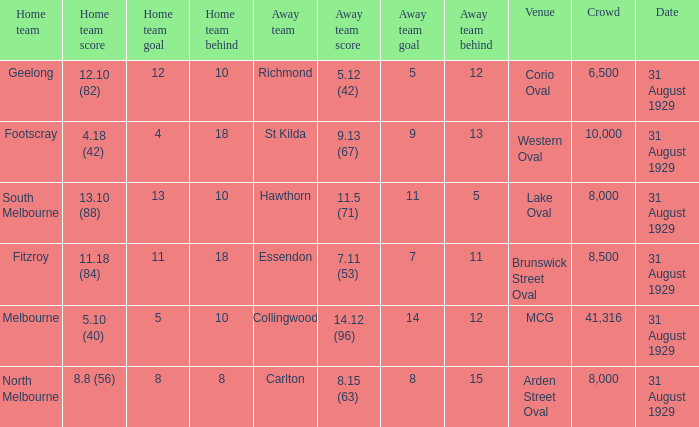What was the away team when the game was at corio oval? Richmond. 